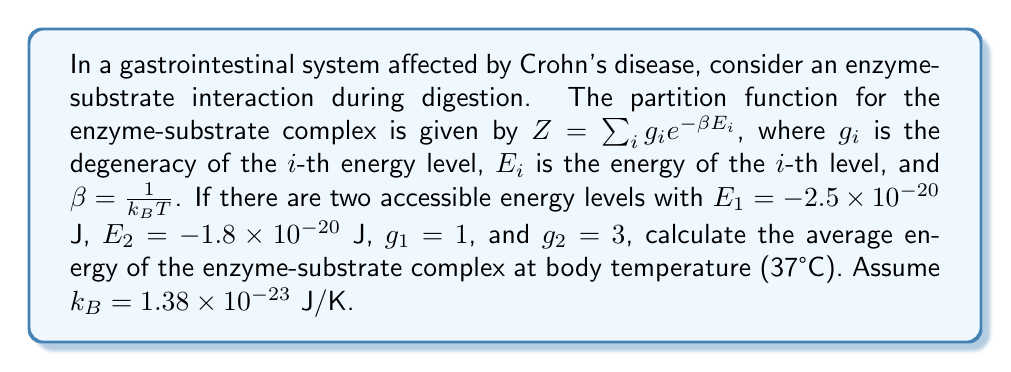Teach me how to tackle this problem. To solve this problem, we'll follow these steps:

1) First, calculate $\beta = \frac{1}{k_B T}$:
   $T = 37°C + 273.15 = 310.15$ K
   $\beta = \frac{1}{(1.38 \times 10^{-23} \text{ J/K})(310.15 \text{ K})} = 2.33 \times 10^{20}$ J$^{-1}$

2) Calculate the partition function $Z$:
   $Z = g_1 e^{-\beta E_1} + g_2 e^{-\beta E_2}$
   $Z = 1 \cdot e^{-(2.33 \times 10^{20})((-2.5 \times 10^{-20}))} + 3 \cdot e^{-(2.33 \times 10^{20})((-1.8 \times 10^{-20}))}$
   $Z = e^{0.5825} + 3e^{0.4194} = 1.7905 + 4.5702 = 6.3607$

3) The average energy is given by:
   $$\langle E \rangle = -\frac{\partial \ln Z}{\partial \beta} = \frac{1}{Z} \sum_{i} E_i g_i e^{-\beta E_i}$$

4) Calculate the sum:
   $\sum_{i} E_i g_i e^{-\beta E_i} = E_1 g_1 e^{-\beta E_1} + E_2 g_2 e^{-\beta E_2}$
   $= (-2.5 \times 10^{-20})(1)(1.7905) + (-1.8 \times 10^{-20})(3)(1.5234)$
   $= -4.4763 \times 10^{-20} - 8.2264 \times 10^{-20} = -1.2703 \times 10^{-19}$ J

5) Finally, calculate the average energy:
   $$\langle E \rangle = \frac{-1.2703 \times 10^{-19}}{6.3607} = -1.9971 \times 10^{-20}$$ J
Answer: $-1.9971 \times 10^{-20}$ J 